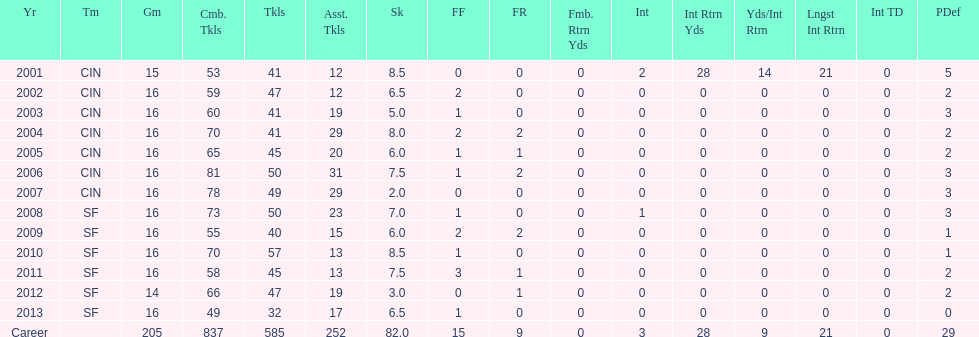How many seasons had combined tackles of 70 or more? 5. 